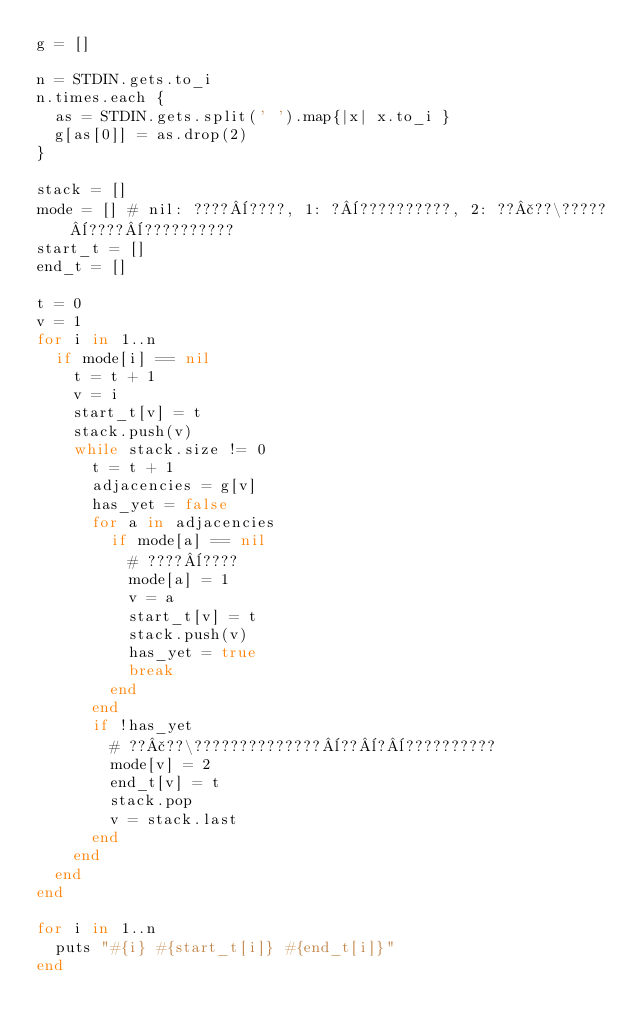Convert code to text. <code><loc_0><loc_0><loc_500><loc_500><_Ruby_>g = []

n = STDIN.gets.to_i
n.times.each {
  as = STDIN.gets.split(' ').map{|x| x.to_i }
  g[as[0]] = as.drop(2)
}

stack = []
mode = [] # nil: ????¨????, 1: ?¨??????????, 2: ??£??\?????¨????¨??????????
start_t = []
end_t = []

t = 0
v = 1
for i in 1..n
  if mode[i] == nil
    t = t + 1
    v = i
    start_t[v] = t
    stack.push(v)
    while stack.size != 0
      t = t + 1
      adjacencies = g[v]
      has_yet = false
      for a in adjacencies
        if mode[a] == nil
          # ????¨????
          mode[a] = 1
          v = a
          start_t[v] = t
          stack.push(v)
          has_yet = true
          break
        end
      end
      if !has_yet
        # ??£??\??????????????¨??¨?¨??????????
        mode[v] = 2
        end_t[v] = t
        stack.pop
        v = stack.last
      end
    end
  end
end

for i in 1..n
  puts "#{i} #{start_t[i]} #{end_t[i]}"
end</code> 